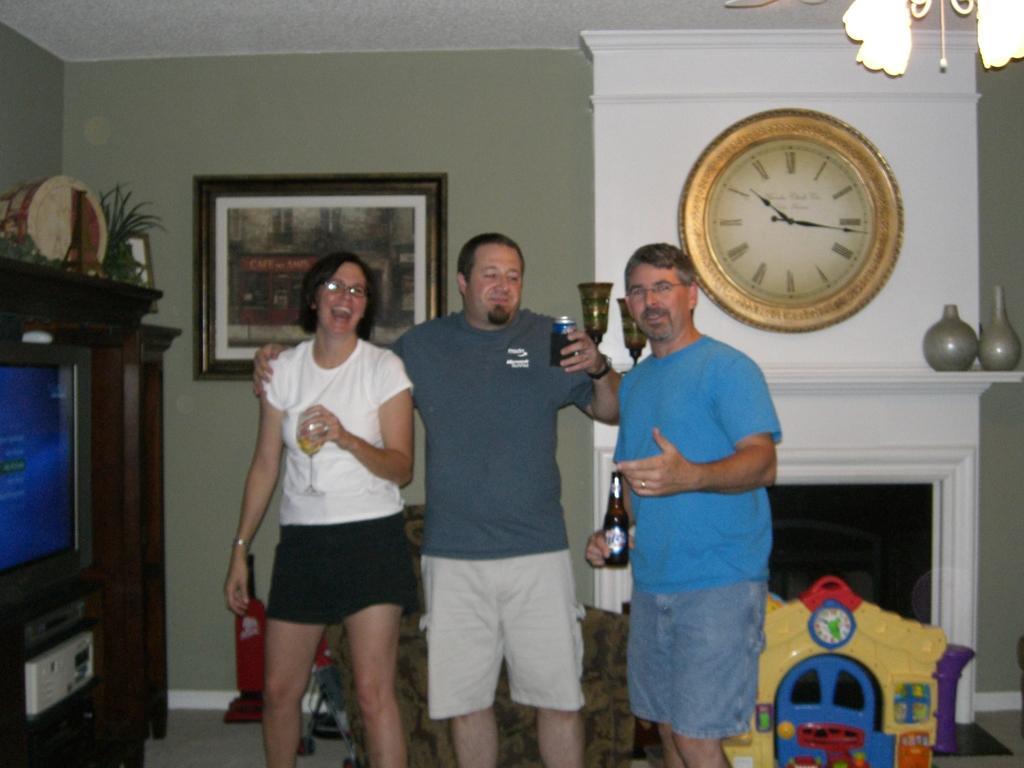Can you describe this image briefly? In this image we can see there are three people, one girl and two boys. The girl is holding a glass of drink and the boy is holding a beer bottle, beside them there is a toy house. At the top of the toy house there is a clock attached to the wall and flower pots. On the left side of the image there is a TV on the table, above the table there are some plants. In the background of the image there is a photo frame attached to the wall and some objects is placed in the floor. 